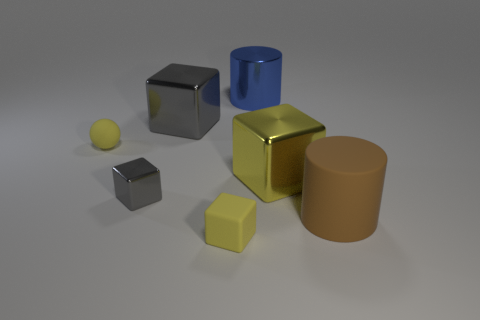Subtract all shiny cubes. How many cubes are left? 1 Subtract all brown cylinders. How many cylinders are left? 1 Subtract 1 blocks. How many blocks are left? 3 Subtract all gray balls. How many blue cylinders are left? 1 Add 4 small metal things. How many small metal things exist? 5 Add 3 large rubber cylinders. How many objects exist? 10 Subtract 0 purple cubes. How many objects are left? 7 Subtract all cylinders. How many objects are left? 5 Subtract all yellow cylinders. Subtract all red blocks. How many cylinders are left? 2 Subtract all brown shiny cylinders. Subtract all large blue metallic cylinders. How many objects are left? 6 